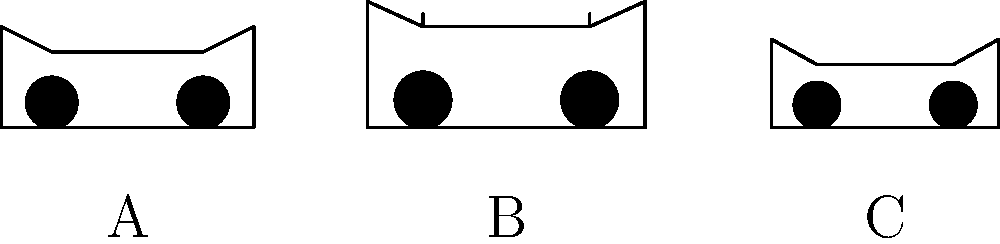After learning about electric vehicles in your school presentation, you're now curious about identifying different types of electric cars. Look at the silhouettes of three electric vehicles labeled A, B, and C. Which silhouette represents an electric SUV (Sport Utility Vehicle)? To identify the electric SUV from the silhouettes, let's analyze each vehicle's characteristics:

1. Silhouette A:
   - Lower overall height
   - Smooth, streamlined roof
   - Shorter wheelbase
   These features suggest a sedan or compact car.

2. Silhouette B:
   - Taller overall height
   - Higher roof line
   - Longer wheelbase
   - Visible roof rails or raised roof edge
   These features are typical of an SUV.

3. Silhouette C:
   - Very low overall height
   - Sleek, aerodynamic profile
   - Shorter wheelbase
   These features indicate a sports car.

The key characteristics of an SUV include a taller body, higher ground clearance, and often visible roof rails or a boxier shape. Among the three silhouettes, only B displays these SUV-specific features.
Answer: B 